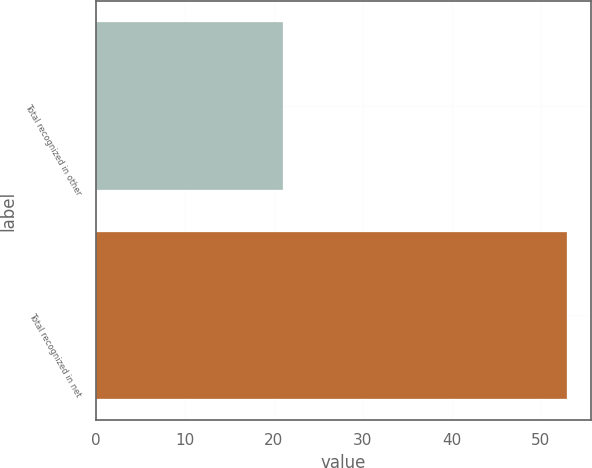Convert chart to OTSL. <chart><loc_0><loc_0><loc_500><loc_500><bar_chart><fcel>Total recognized in other<fcel>Total recognized in net<nl><fcel>21<fcel>53<nl></chart> 